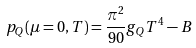Convert formula to latex. <formula><loc_0><loc_0><loc_500><loc_500>p _ { Q } ( \mu = 0 , T ) = { \frac { \pi ^ { 2 } } { 9 0 } } g _ { Q } T ^ { 4 } - B \,</formula> 